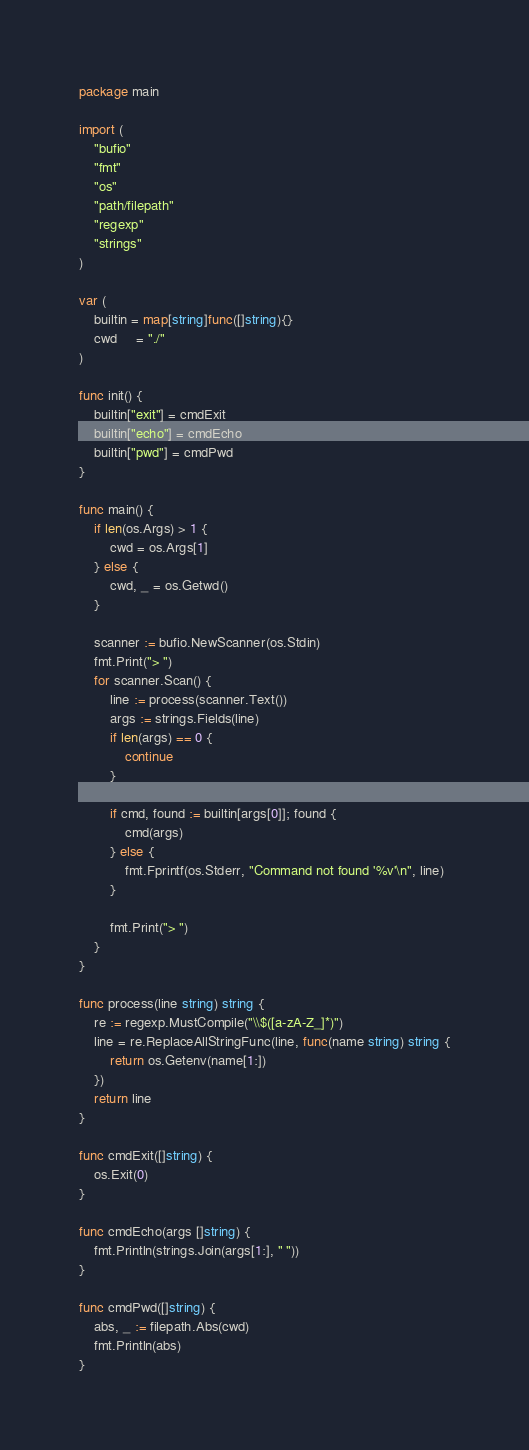Convert code to text. <code><loc_0><loc_0><loc_500><loc_500><_Go_>package main

import (
	"bufio"
	"fmt"
	"os"
	"path/filepath"
	"regexp"
	"strings"
)

var (
	builtin = map[string]func([]string){}
	cwd     = "./"
)

func init() {
	builtin["exit"] = cmdExit
	builtin["echo"] = cmdEcho
	builtin["pwd"] = cmdPwd
}

func main() {
	if len(os.Args) > 1 {
		cwd = os.Args[1]
	} else {
		cwd, _ = os.Getwd()
	}

	scanner := bufio.NewScanner(os.Stdin)
	fmt.Print("> ")
	for scanner.Scan() {
		line := process(scanner.Text())
		args := strings.Fields(line)
		if len(args) == 0 {
			continue
		}

		if cmd, found := builtin[args[0]]; found {
			cmd(args)
		} else {
			fmt.Fprintf(os.Stderr, "Command not found '%v'\n", line)
		}

		fmt.Print("> ")
	}
}

func process(line string) string {
	re := regexp.MustCompile("\\$([a-zA-Z_]*)")
	line = re.ReplaceAllStringFunc(line, func(name string) string {
		return os.Getenv(name[1:])
	})
	return line
}

func cmdExit([]string) {
	os.Exit(0)
}

func cmdEcho(args []string) {
	fmt.Println(strings.Join(args[1:], " "))
}

func cmdPwd([]string) {
	abs, _ := filepath.Abs(cwd)
	fmt.Println(abs)
}
</code> 